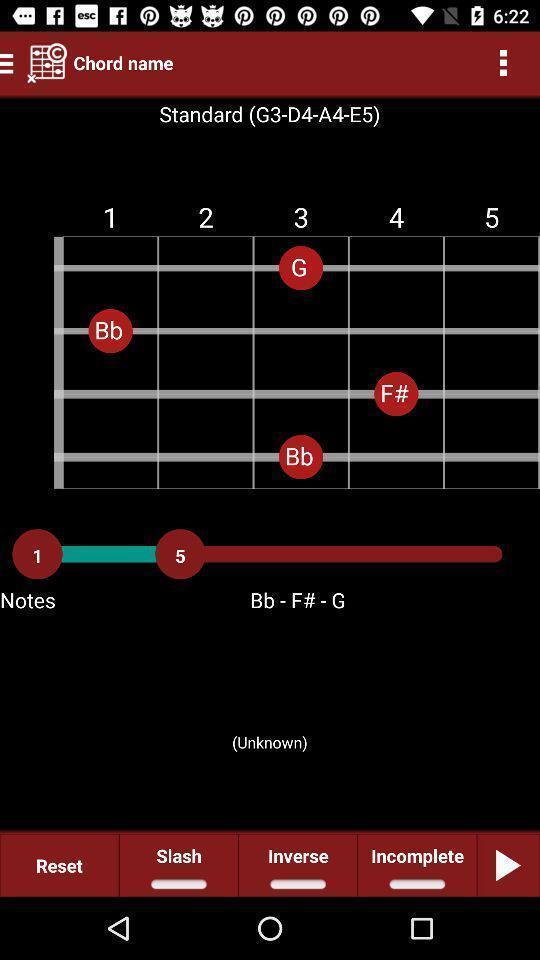Summarize the main components in this picture. Page showing information about music. 